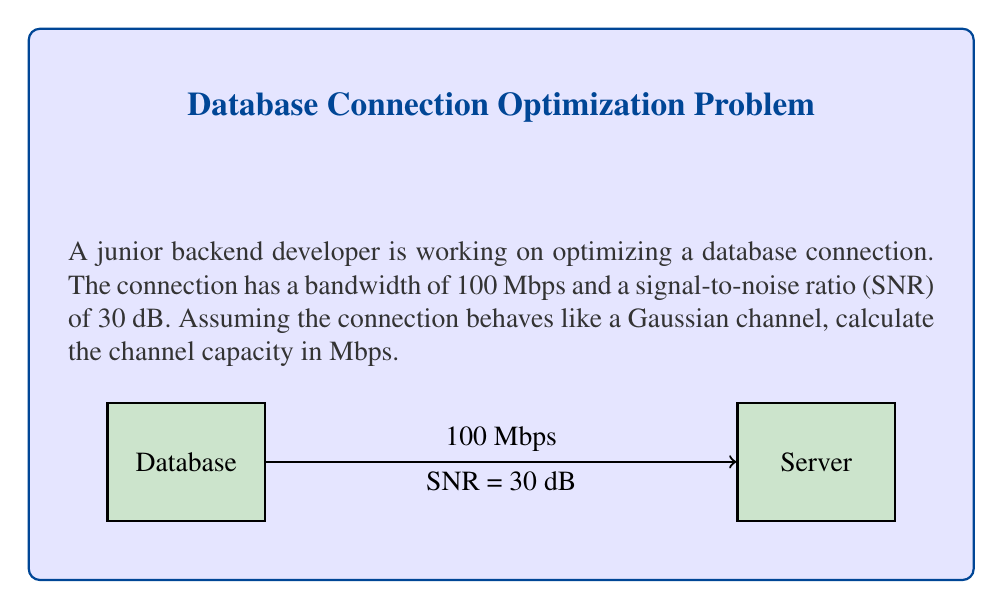Could you help me with this problem? To solve this problem, we'll use the Shannon-Hartley theorem, which gives the channel capacity for a Gaussian channel:

$$C = B \log_2(1 + SNR)$$

Where:
$C$ is the channel capacity in bits per second
$B$ is the bandwidth in Hz
$SNR$ is the linear signal-to-noise ratio

Step 1: Convert bandwidth from Mbps to Hz
100 Mbps = 100 × 10^6 Hz = 10^8 Hz

Step 2: Convert SNR from dB to linear scale
$SNR_{linear} = 10^{(SNR_{dB}/10)} = 10^{(30/10)} = 10^3 = 1000$

Step 3: Apply the Shannon-Hartley theorem
$$\begin{align}
C &= B \log_2(1 + SNR) \\
&= 10^8 \log_2(1 + 1000) \\
&≈ 10^8 \times 9.97 \\
&≈ 9.97 \times 10^8 \text{ bits per second}
\end{align}$$

Step 4: Convert the result to Mbps
$$9.97 \times 10^8 \text{ bps} = 997 \text{ Mbps}$$

Therefore, the channel capacity of the database connection is approximately 997 Mbps.
Answer: 997 Mbps 